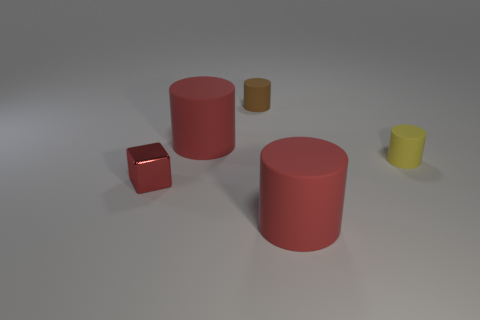Add 2 green things. How many objects exist? 7 Subtract all cylinders. How many objects are left? 1 Add 2 tiny yellow cylinders. How many tiny yellow cylinders are left? 3 Add 5 brown matte balls. How many brown matte balls exist? 5 Subtract 0 blue spheres. How many objects are left? 5 Subtract all large matte spheres. Subtract all large cylinders. How many objects are left? 3 